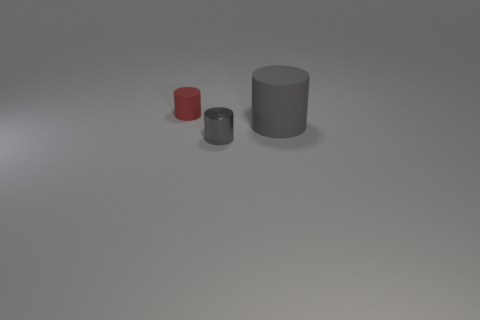Subtract all matte cylinders. How many cylinders are left? 1 Add 1 blue cubes. How many objects exist? 4 Add 3 big rubber cylinders. How many big rubber cylinders are left? 4 Add 1 gray things. How many gray things exist? 3 Subtract 0 brown cubes. How many objects are left? 3 Subtract all gray shiny cylinders. Subtract all large brown matte cylinders. How many objects are left? 2 